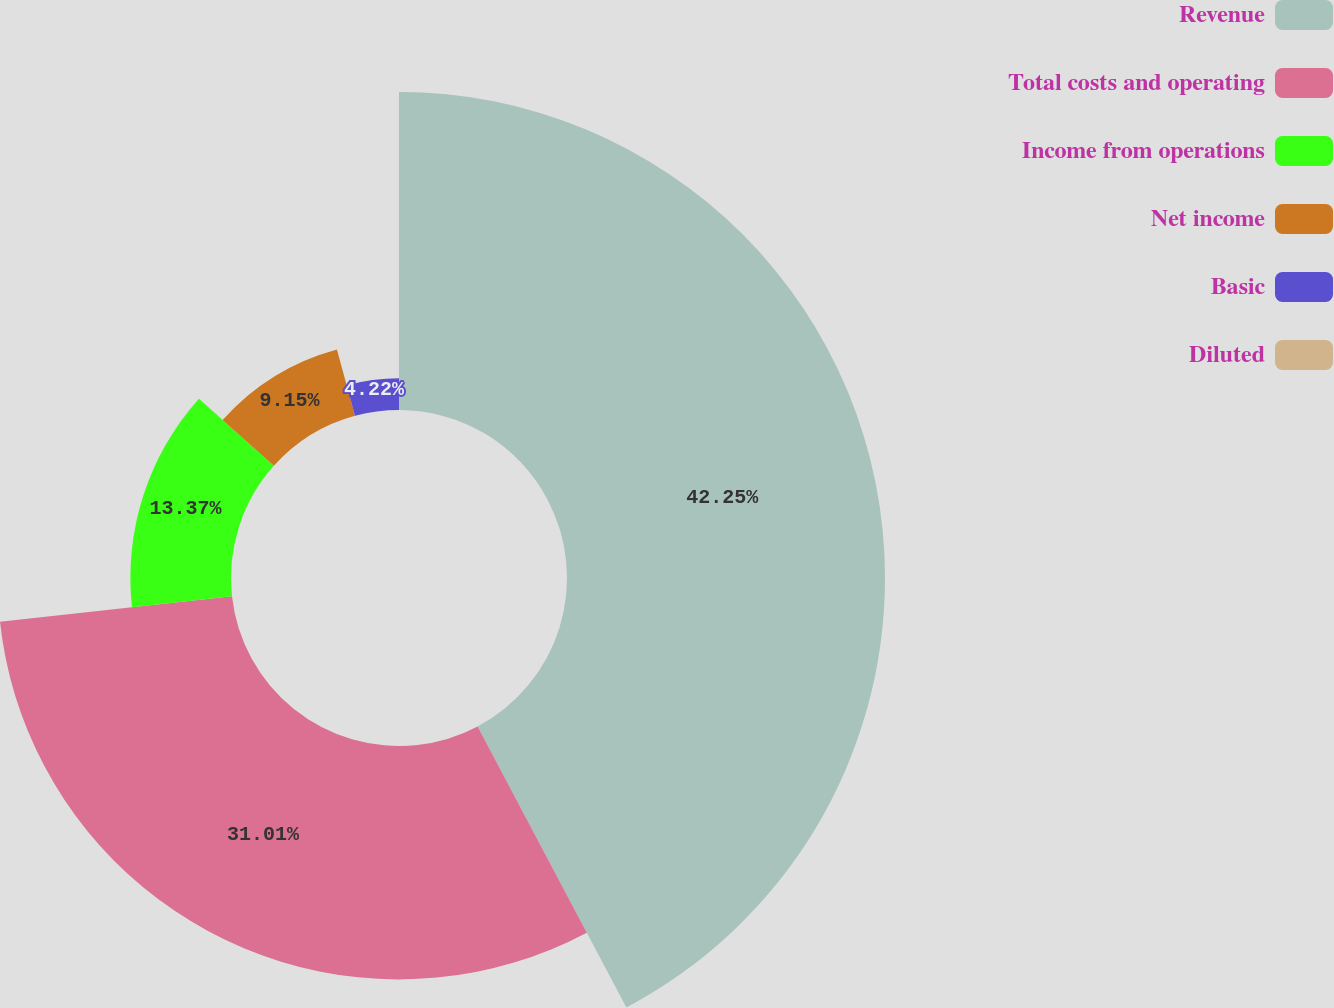<chart> <loc_0><loc_0><loc_500><loc_500><pie_chart><fcel>Revenue<fcel>Total costs and operating<fcel>Income from operations<fcel>Net income<fcel>Basic<fcel>Diluted<nl><fcel>42.25%<fcel>31.01%<fcel>13.37%<fcel>9.15%<fcel>4.22%<fcel>0.0%<nl></chart> 